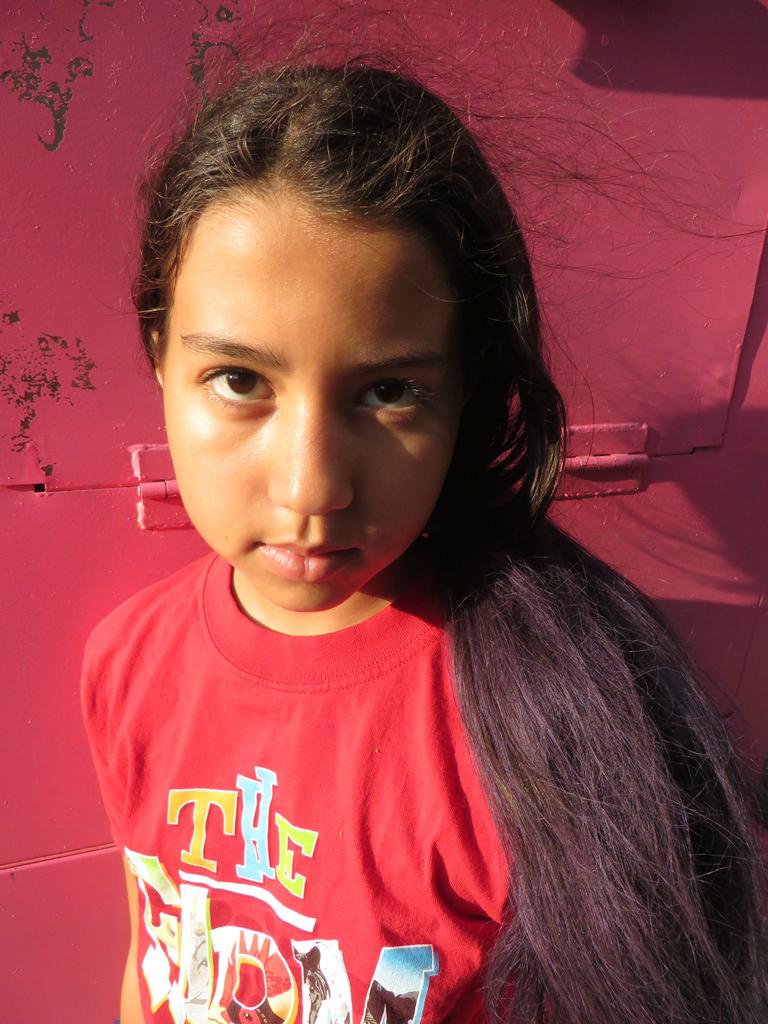What does her shirt say?
Offer a terse response. The. 